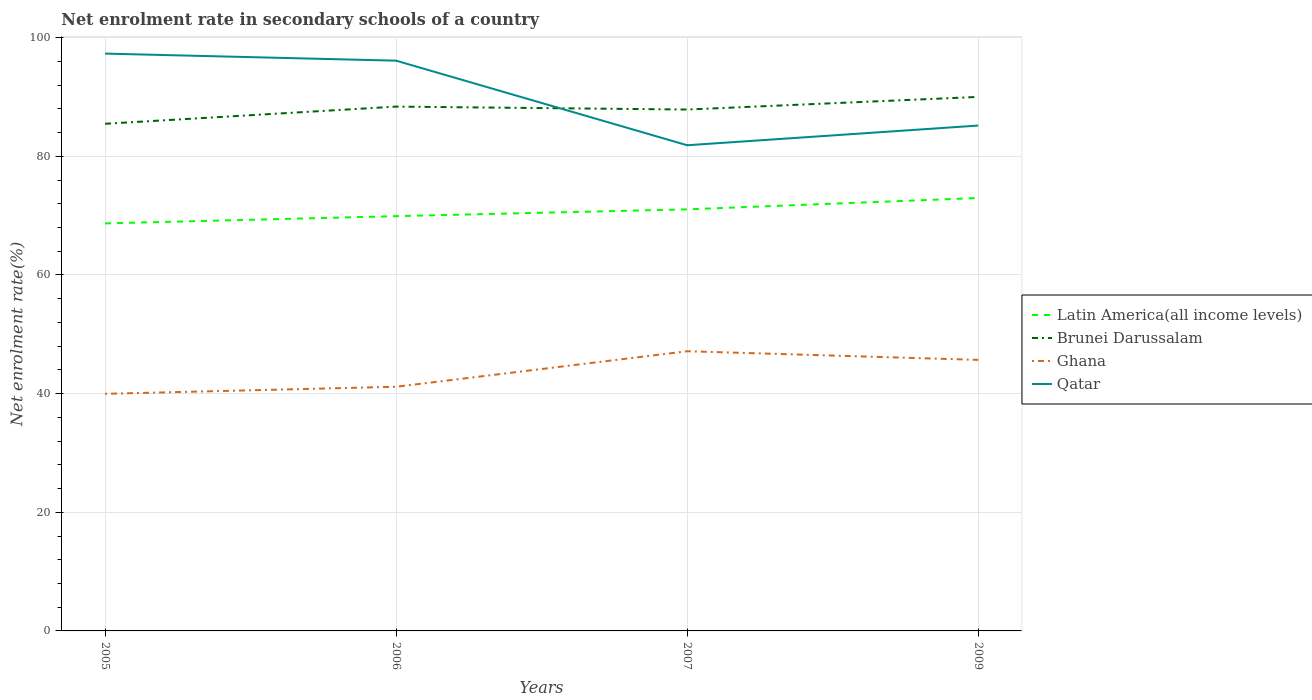Does the line corresponding to Qatar intersect with the line corresponding to Brunei Darussalam?
Your response must be concise. Yes. Is the number of lines equal to the number of legend labels?
Keep it short and to the point. Yes. Across all years, what is the maximum net enrolment rate in secondary schools in Latin America(all income levels)?
Your response must be concise. 68.69. What is the total net enrolment rate in secondary schools in Latin America(all income levels) in the graph?
Keep it short and to the point. -1.15. What is the difference between the highest and the second highest net enrolment rate in secondary schools in Qatar?
Offer a terse response. 15.45. What is the difference between the highest and the lowest net enrolment rate in secondary schools in Brunei Darussalam?
Your answer should be compact. 2. How many lines are there?
Offer a very short reply. 4. Are the values on the major ticks of Y-axis written in scientific E-notation?
Keep it short and to the point. No. Does the graph contain any zero values?
Ensure brevity in your answer.  No. Does the graph contain grids?
Your answer should be compact. Yes. What is the title of the graph?
Provide a short and direct response. Net enrolment rate in secondary schools of a country. Does "Uganda" appear as one of the legend labels in the graph?
Give a very brief answer. No. What is the label or title of the Y-axis?
Your response must be concise. Net enrolment rate(%). What is the Net enrolment rate(%) in Latin America(all income levels) in 2005?
Ensure brevity in your answer.  68.69. What is the Net enrolment rate(%) of Brunei Darussalam in 2005?
Offer a very short reply. 85.49. What is the Net enrolment rate(%) in Ghana in 2005?
Your answer should be very brief. 39.97. What is the Net enrolment rate(%) of Qatar in 2005?
Provide a succinct answer. 97.32. What is the Net enrolment rate(%) in Latin America(all income levels) in 2006?
Make the answer very short. 69.92. What is the Net enrolment rate(%) in Brunei Darussalam in 2006?
Your answer should be compact. 88.38. What is the Net enrolment rate(%) in Ghana in 2006?
Your response must be concise. 41.16. What is the Net enrolment rate(%) in Qatar in 2006?
Keep it short and to the point. 96.13. What is the Net enrolment rate(%) in Latin America(all income levels) in 2007?
Provide a short and direct response. 71.06. What is the Net enrolment rate(%) of Brunei Darussalam in 2007?
Give a very brief answer. 87.89. What is the Net enrolment rate(%) of Ghana in 2007?
Provide a short and direct response. 47.15. What is the Net enrolment rate(%) in Qatar in 2007?
Your answer should be very brief. 81.87. What is the Net enrolment rate(%) of Latin America(all income levels) in 2009?
Offer a very short reply. 72.98. What is the Net enrolment rate(%) of Brunei Darussalam in 2009?
Provide a succinct answer. 90.02. What is the Net enrolment rate(%) of Ghana in 2009?
Give a very brief answer. 45.69. What is the Net enrolment rate(%) in Qatar in 2009?
Provide a succinct answer. 85.19. Across all years, what is the maximum Net enrolment rate(%) of Latin America(all income levels)?
Your answer should be very brief. 72.98. Across all years, what is the maximum Net enrolment rate(%) of Brunei Darussalam?
Your answer should be compact. 90.02. Across all years, what is the maximum Net enrolment rate(%) of Ghana?
Keep it short and to the point. 47.15. Across all years, what is the maximum Net enrolment rate(%) of Qatar?
Provide a succinct answer. 97.32. Across all years, what is the minimum Net enrolment rate(%) of Latin America(all income levels)?
Offer a very short reply. 68.69. Across all years, what is the minimum Net enrolment rate(%) in Brunei Darussalam?
Your response must be concise. 85.49. Across all years, what is the minimum Net enrolment rate(%) of Ghana?
Offer a very short reply. 39.97. Across all years, what is the minimum Net enrolment rate(%) of Qatar?
Ensure brevity in your answer.  81.87. What is the total Net enrolment rate(%) of Latin America(all income levels) in the graph?
Your response must be concise. 282.65. What is the total Net enrolment rate(%) of Brunei Darussalam in the graph?
Make the answer very short. 351.78. What is the total Net enrolment rate(%) in Ghana in the graph?
Keep it short and to the point. 173.96. What is the total Net enrolment rate(%) of Qatar in the graph?
Make the answer very short. 360.51. What is the difference between the Net enrolment rate(%) of Latin America(all income levels) in 2005 and that in 2006?
Your response must be concise. -1.22. What is the difference between the Net enrolment rate(%) in Brunei Darussalam in 2005 and that in 2006?
Ensure brevity in your answer.  -2.9. What is the difference between the Net enrolment rate(%) in Ghana in 2005 and that in 2006?
Provide a succinct answer. -1.19. What is the difference between the Net enrolment rate(%) in Qatar in 2005 and that in 2006?
Provide a short and direct response. 1.19. What is the difference between the Net enrolment rate(%) of Latin America(all income levels) in 2005 and that in 2007?
Offer a very short reply. -2.37. What is the difference between the Net enrolment rate(%) of Brunei Darussalam in 2005 and that in 2007?
Keep it short and to the point. -2.4. What is the difference between the Net enrolment rate(%) in Ghana in 2005 and that in 2007?
Provide a short and direct response. -7.18. What is the difference between the Net enrolment rate(%) of Qatar in 2005 and that in 2007?
Ensure brevity in your answer.  15.45. What is the difference between the Net enrolment rate(%) in Latin America(all income levels) in 2005 and that in 2009?
Your answer should be compact. -4.28. What is the difference between the Net enrolment rate(%) in Brunei Darussalam in 2005 and that in 2009?
Keep it short and to the point. -4.53. What is the difference between the Net enrolment rate(%) in Ghana in 2005 and that in 2009?
Your answer should be compact. -5.72. What is the difference between the Net enrolment rate(%) in Qatar in 2005 and that in 2009?
Ensure brevity in your answer.  12.13. What is the difference between the Net enrolment rate(%) in Latin America(all income levels) in 2006 and that in 2007?
Provide a short and direct response. -1.15. What is the difference between the Net enrolment rate(%) in Brunei Darussalam in 2006 and that in 2007?
Provide a succinct answer. 0.49. What is the difference between the Net enrolment rate(%) of Ghana in 2006 and that in 2007?
Offer a very short reply. -5.99. What is the difference between the Net enrolment rate(%) in Qatar in 2006 and that in 2007?
Your answer should be compact. 14.26. What is the difference between the Net enrolment rate(%) in Latin America(all income levels) in 2006 and that in 2009?
Provide a short and direct response. -3.06. What is the difference between the Net enrolment rate(%) in Brunei Darussalam in 2006 and that in 2009?
Provide a short and direct response. -1.64. What is the difference between the Net enrolment rate(%) of Ghana in 2006 and that in 2009?
Offer a terse response. -4.53. What is the difference between the Net enrolment rate(%) in Qatar in 2006 and that in 2009?
Make the answer very short. 10.94. What is the difference between the Net enrolment rate(%) in Latin America(all income levels) in 2007 and that in 2009?
Keep it short and to the point. -1.91. What is the difference between the Net enrolment rate(%) of Brunei Darussalam in 2007 and that in 2009?
Provide a short and direct response. -2.13. What is the difference between the Net enrolment rate(%) in Ghana in 2007 and that in 2009?
Offer a very short reply. 1.46. What is the difference between the Net enrolment rate(%) of Qatar in 2007 and that in 2009?
Provide a short and direct response. -3.32. What is the difference between the Net enrolment rate(%) in Latin America(all income levels) in 2005 and the Net enrolment rate(%) in Brunei Darussalam in 2006?
Make the answer very short. -19.69. What is the difference between the Net enrolment rate(%) in Latin America(all income levels) in 2005 and the Net enrolment rate(%) in Ghana in 2006?
Your answer should be very brief. 27.54. What is the difference between the Net enrolment rate(%) in Latin America(all income levels) in 2005 and the Net enrolment rate(%) in Qatar in 2006?
Provide a succinct answer. -27.43. What is the difference between the Net enrolment rate(%) in Brunei Darussalam in 2005 and the Net enrolment rate(%) in Ghana in 2006?
Your response must be concise. 44.33. What is the difference between the Net enrolment rate(%) of Brunei Darussalam in 2005 and the Net enrolment rate(%) of Qatar in 2006?
Offer a terse response. -10.64. What is the difference between the Net enrolment rate(%) in Ghana in 2005 and the Net enrolment rate(%) in Qatar in 2006?
Make the answer very short. -56.16. What is the difference between the Net enrolment rate(%) in Latin America(all income levels) in 2005 and the Net enrolment rate(%) in Brunei Darussalam in 2007?
Give a very brief answer. -19.2. What is the difference between the Net enrolment rate(%) in Latin America(all income levels) in 2005 and the Net enrolment rate(%) in Ghana in 2007?
Ensure brevity in your answer.  21.55. What is the difference between the Net enrolment rate(%) in Latin America(all income levels) in 2005 and the Net enrolment rate(%) in Qatar in 2007?
Offer a very short reply. -13.18. What is the difference between the Net enrolment rate(%) in Brunei Darussalam in 2005 and the Net enrolment rate(%) in Ghana in 2007?
Give a very brief answer. 38.34. What is the difference between the Net enrolment rate(%) in Brunei Darussalam in 2005 and the Net enrolment rate(%) in Qatar in 2007?
Offer a very short reply. 3.62. What is the difference between the Net enrolment rate(%) of Ghana in 2005 and the Net enrolment rate(%) of Qatar in 2007?
Ensure brevity in your answer.  -41.9. What is the difference between the Net enrolment rate(%) of Latin America(all income levels) in 2005 and the Net enrolment rate(%) of Brunei Darussalam in 2009?
Make the answer very short. -21.33. What is the difference between the Net enrolment rate(%) of Latin America(all income levels) in 2005 and the Net enrolment rate(%) of Ghana in 2009?
Your answer should be very brief. 23.01. What is the difference between the Net enrolment rate(%) of Latin America(all income levels) in 2005 and the Net enrolment rate(%) of Qatar in 2009?
Provide a succinct answer. -16.5. What is the difference between the Net enrolment rate(%) of Brunei Darussalam in 2005 and the Net enrolment rate(%) of Ghana in 2009?
Give a very brief answer. 39.8. What is the difference between the Net enrolment rate(%) of Brunei Darussalam in 2005 and the Net enrolment rate(%) of Qatar in 2009?
Offer a very short reply. 0.3. What is the difference between the Net enrolment rate(%) of Ghana in 2005 and the Net enrolment rate(%) of Qatar in 2009?
Provide a succinct answer. -45.22. What is the difference between the Net enrolment rate(%) of Latin America(all income levels) in 2006 and the Net enrolment rate(%) of Brunei Darussalam in 2007?
Give a very brief answer. -17.97. What is the difference between the Net enrolment rate(%) of Latin America(all income levels) in 2006 and the Net enrolment rate(%) of Ghana in 2007?
Your answer should be compact. 22.77. What is the difference between the Net enrolment rate(%) of Latin America(all income levels) in 2006 and the Net enrolment rate(%) of Qatar in 2007?
Offer a very short reply. -11.95. What is the difference between the Net enrolment rate(%) of Brunei Darussalam in 2006 and the Net enrolment rate(%) of Ghana in 2007?
Your answer should be very brief. 41.24. What is the difference between the Net enrolment rate(%) of Brunei Darussalam in 2006 and the Net enrolment rate(%) of Qatar in 2007?
Keep it short and to the point. 6.51. What is the difference between the Net enrolment rate(%) of Ghana in 2006 and the Net enrolment rate(%) of Qatar in 2007?
Your response must be concise. -40.71. What is the difference between the Net enrolment rate(%) in Latin America(all income levels) in 2006 and the Net enrolment rate(%) in Brunei Darussalam in 2009?
Offer a very short reply. -20.1. What is the difference between the Net enrolment rate(%) in Latin America(all income levels) in 2006 and the Net enrolment rate(%) in Ghana in 2009?
Your answer should be very brief. 24.23. What is the difference between the Net enrolment rate(%) of Latin America(all income levels) in 2006 and the Net enrolment rate(%) of Qatar in 2009?
Your response must be concise. -15.27. What is the difference between the Net enrolment rate(%) in Brunei Darussalam in 2006 and the Net enrolment rate(%) in Ghana in 2009?
Your response must be concise. 42.7. What is the difference between the Net enrolment rate(%) in Brunei Darussalam in 2006 and the Net enrolment rate(%) in Qatar in 2009?
Give a very brief answer. 3.19. What is the difference between the Net enrolment rate(%) of Ghana in 2006 and the Net enrolment rate(%) of Qatar in 2009?
Provide a succinct answer. -44.03. What is the difference between the Net enrolment rate(%) in Latin America(all income levels) in 2007 and the Net enrolment rate(%) in Brunei Darussalam in 2009?
Offer a very short reply. -18.96. What is the difference between the Net enrolment rate(%) of Latin America(all income levels) in 2007 and the Net enrolment rate(%) of Ghana in 2009?
Your response must be concise. 25.38. What is the difference between the Net enrolment rate(%) in Latin America(all income levels) in 2007 and the Net enrolment rate(%) in Qatar in 2009?
Offer a very short reply. -14.13. What is the difference between the Net enrolment rate(%) in Brunei Darussalam in 2007 and the Net enrolment rate(%) in Ghana in 2009?
Your answer should be compact. 42.2. What is the difference between the Net enrolment rate(%) in Brunei Darussalam in 2007 and the Net enrolment rate(%) in Qatar in 2009?
Your response must be concise. 2.7. What is the difference between the Net enrolment rate(%) in Ghana in 2007 and the Net enrolment rate(%) in Qatar in 2009?
Offer a very short reply. -38.05. What is the average Net enrolment rate(%) of Latin America(all income levels) per year?
Make the answer very short. 70.66. What is the average Net enrolment rate(%) of Brunei Darussalam per year?
Your response must be concise. 87.95. What is the average Net enrolment rate(%) in Ghana per year?
Provide a succinct answer. 43.49. What is the average Net enrolment rate(%) in Qatar per year?
Make the answer very short. 90.13. In the year 2005, what is the difference between the Net enrolment rate(%) in Latin America(all income levels) and Net enrolment rate(%) in Brunei Darussalam?
Your answer should be very brief. -16.79. In the year 2005, what is the difference between the Net enrolment rate(%) of Latin America(all income levels) and Net enrolment rate(%) of Ghana?
Your answer should be compact. 28.73. In the year 2005, what is the difference between the Net enrolment rate(%) of Latin America(all income levels) and Net enrolment rate(%) of Qatar?
Offer a very short reply. -28.63. In the year 2005, what is the difference between the Net enrolment rate(%) in Brunei Darussalam and Net enrolment rate(%) in Ghana?
Provide a succinct answer. 45.52. In the year 2005, what is the difference between the Net enrolment rate(%) in Brunei Darussalam and Net enrolment rate(%) in Qatar?
Make the answer very short. -11.83. In the year 2005, what is the difference between the Net enrolment rate(%) of Ghana and Net enrolment rate(%) of Qatar?
Keep it short and to the point. -57.35. In the year 2006, what is the difference between the Net enrolment rate(%) of Latin America(all income levels) and Net enrolment rate(%) of Brunei Darussalam?
Keep it short and to the point. -18.47. In the year 2006, what is the difference between the Net enrolment rate(%) in Latin America(all income levels) and Net enrolment rate(%) in Ghana?
Give a very brief answer. 28.76. In the year 2006, what is the difference between the Net enrolment rate(%) of Latin America(all income levels) and Net enrolment rate(%) of Qatar?
Your answer should be compact. -26.21. In the year 2006, what is the difference between the Net enrolment rate(%) of Brunei Darussalam and Net enrolment rate(%) of Ghana?
Provide a succinct answer. 47.23. In the year 2006, what is the difference between the Net enrolment rate(%) of Brunei Darussalam and Net enrolment rate(%) of Qatar?
Offer a terse response. -7.74. In the year 2006, what is the difference between the Net enrolment rate(%) of Ghana and Net enrolment rate(%) of Qatar?
Make the answer very short. -54.97. In the year 2007, what is the difference between the Net enrolment rate(%) of Latin America(all income levels) and Net enrolment rate(%) of Brunei Darussalam?
Make the answer very short. -16.83. In the year 2007, what is the difference between the Net enrolment rate(%) in Latin America(all income levels) and Net enrolment rate(%) in Ghana?
Give a very brief answer. 23.92. In the year 2007, what is the difference between the Net enrolment rate(%) in Latin America(all income levels) and Net enrolment rate(%) in Qatar?
Provide a succinct answer. -10.81. In the year 2007, what is the difference between the Net enrolment rate(%) of Brunei Darussalam and Net enrolment rate(%) of Ghana?
Offer a very short reply. 40.74. In the year 2007, what is the difference between the Net enrolment rate(%) of Brunei Darussalam and Net enrolment rate(%) of Qatar?
Provide a succinct answer. 6.02. In the year 2007, what is the difference between the Net enrolment rate(%) in Ghana and Net enrolment rate(%) in Qatar?
Your answer should be compact. -34.72. In the year 2009, what is the difference between the Net enrolment rate(%) in Latin America(all income levels) and Net enrolment rate(%) in Brunei Darussalam?
Provide a succinct answer. -17.04. In the year 2009, what is the difference between the Net enrolment rate(%) of Latin America(all income levels) and Net enrolment rate(%) of Ghana?
Offer a terse response. 27.29. In the year 2009, what is the difference between the Net enrolment rate(%) of Latin America(all income levels) and Net enrolment rate(%) of Qatar?
Make the answer very short. -12.21. In the year 2009, what is the difference between the Net enrolment rate(%) in Brunei Darussalam and Net enrolment rate(%) in Ghana?
Your answer should be very brief. 44.33. In the year 2009, what is the difference between the Net enrolment rate(%) of Brunei Darussalam and Net enrolment rate(%) of Qatar?
Give a very brief answer. 4.83. In the year 2009, what is the difference between the Net enrolment rate(%) in Ghana and Net enrolment rate(%) in Qatar?
Make the answer very short. -39.5. What is the ratio of the Net enrolment rate(%) of Latin America(all income levels) in 2005 to that in 2006?
Offer a terse response. 0.98. What is the ratio of the Net enrolment rate(%) in Brunei Darussalam in 2005 to that in 2006?
Offer a terse response. 0.97. What is the ratio of the Net enrolment rate(%) in Ghana in 2005 to that in 2006?
Offer a terse response. 0.97. What is the ratio of the Net enrolment rate(%) in Qatar in 2005 to that in 2006?
Offer a terse response. 1.01. What is the ratio of the Net enrolment rate(%) in Latin America(all income levels) in 2005 to that in 2007?
Your answer should be very brief. 0.97. What is the ratio of the Net enrolment rate(%) in Brunei Darussalam in 2005 to that in 2007?
Your answer should be very brief. 0.97. What is the ratio of the Net enrolment rate(%) in Ghana in 2005 to that in 2007?
Your response must be concise. 0.85. What is the ratio of the Net enrolment rate(%) in Qatar in 2005 to that in 2007?
Make the answer very short. 1.19. What is the ratio of the Net enrolment rate(%) in Latin America(all income levels) in 2005 to that in 2009?
Your answer should be very brief. 0.94. What is the ratio of the Net enrolment rate(%) in Brunei Darussalam in 2005 to that in 2009?
Your answer should be compact. 0.95. What is the ratio of the Net enrolment rate(%) in Ghana in 2005 to that in 2009?
Keep it short and to the point. 0.87. What is the ratio of the Net enrolment rate(%) in Qatar in 2005 to that in 2009?
Offer a very short reply. 1.14. What is the ratio of the Net enrolment rate(%) in Latin America(all income levels) in 2006 to that in 2007?
Offer a terse response. 0.98. What is the ratio of the Net enrolment rate(%) of Brunei Darussalam in 2006 to that in 2007?
Keep it short and to the point. 1.01. What is the ratio of the Net enrolment rate(%) of Ghana in 2006 to that in 2007?
Ensure brevity in your answer.  0.87. What is the ratio of the Net enrolment rate(%) in Qatar in 2006 to that in 2007?
Your answer should be very brief. 1.17. What is the ratio of the Net enrolment rate(%) in Latin America(all income levels) in 2006 to that in 2009?
Ensure brevity in your answer.  0.96. What is the ratio of the Net enrolment rate(%) in Brunei Darussalam in 2006 to that in 2009?
Your answer should be compact. 0.98. What is the ratio of the Net enrolment rate(%) of Ghana in 2006 to that in 2009?
Provide a short and direct response. 0.9. What is the ratio of the Net enrolment rate(%) in Qatar in 2006 to that in 2009?
Provide a succinct answer. 1.13. What is the ratio of the Net enrolment rate(%) in Latin America(all income levels) in 2007 to that in 2009?
Give a very brief answer. 0.97. What is the ratio of the Net enrolment rate(%) in Brunei Darussalam in 2007 to that in 2009?
Your response must be concise. 0.98. What is the ratio of the Net enrolment rate(%) in Ghana in 2007 to that in 2009?
Give a very brief answer. 1.03. What is the difference between the highest and the second highest Net enrolment rate(%) in Latin America(all income levels)?
Give a very brief answer. 1.91. What is the difference between the highest and the second highest Net enrolment rate(%) of Brunei Darussalam?
Make the answer very short. 1.64. What is the difference between the highest and the second highest Net enrolment rate(%) in Ghana?
Offer a terse response. 1.46. What is the difference between the highest and the second highest Net enrolment rate(%) of Qatar?
Make the answer very short. 1.19. What is the difference between the highest and the lowest Net enrolment rate(%) in Latin America(all income levels)?
Provide a succinct answer. 4.28. What is the difference between the highest and the lowest Net enrolment rate(%) of Brunei Darussalam?
Provide a succinct answer. 4.53. What is the difference between the highest and the lowest Net enrolment rate(%) in Ghana?
Ensure brevity in your answer.  7.18. What is the difference between the highest and the lowest Net enrolment rate(%) in Qatar?
Provide a succinct answer. 15.45. 